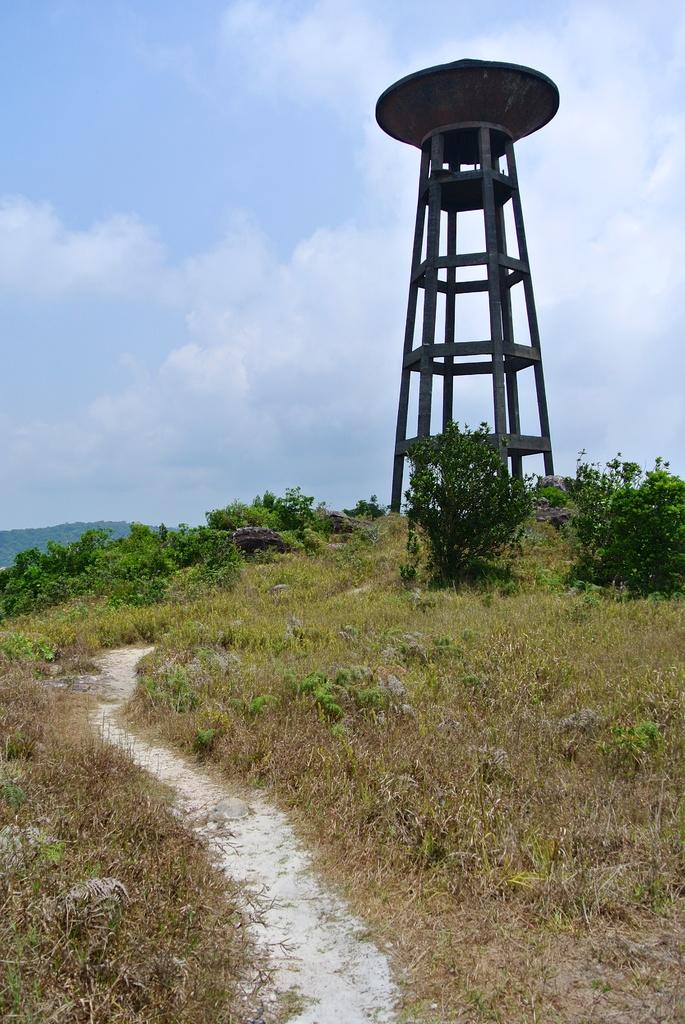What is the main feature of the landscape in the image? There is a lot of grass in the image. Are there any other natural elements present in the image? Yes, there are some plants in the image. What can be seen in the background of the image? There is a tower in the background of the image. What type of machine is visible in the image? There is no machine present in the image; it features a grassy landscape with plants and a tower in the background. What season is depicted in the image? The provided facts do not mention any specific season, so it cannot be determined from the image. 